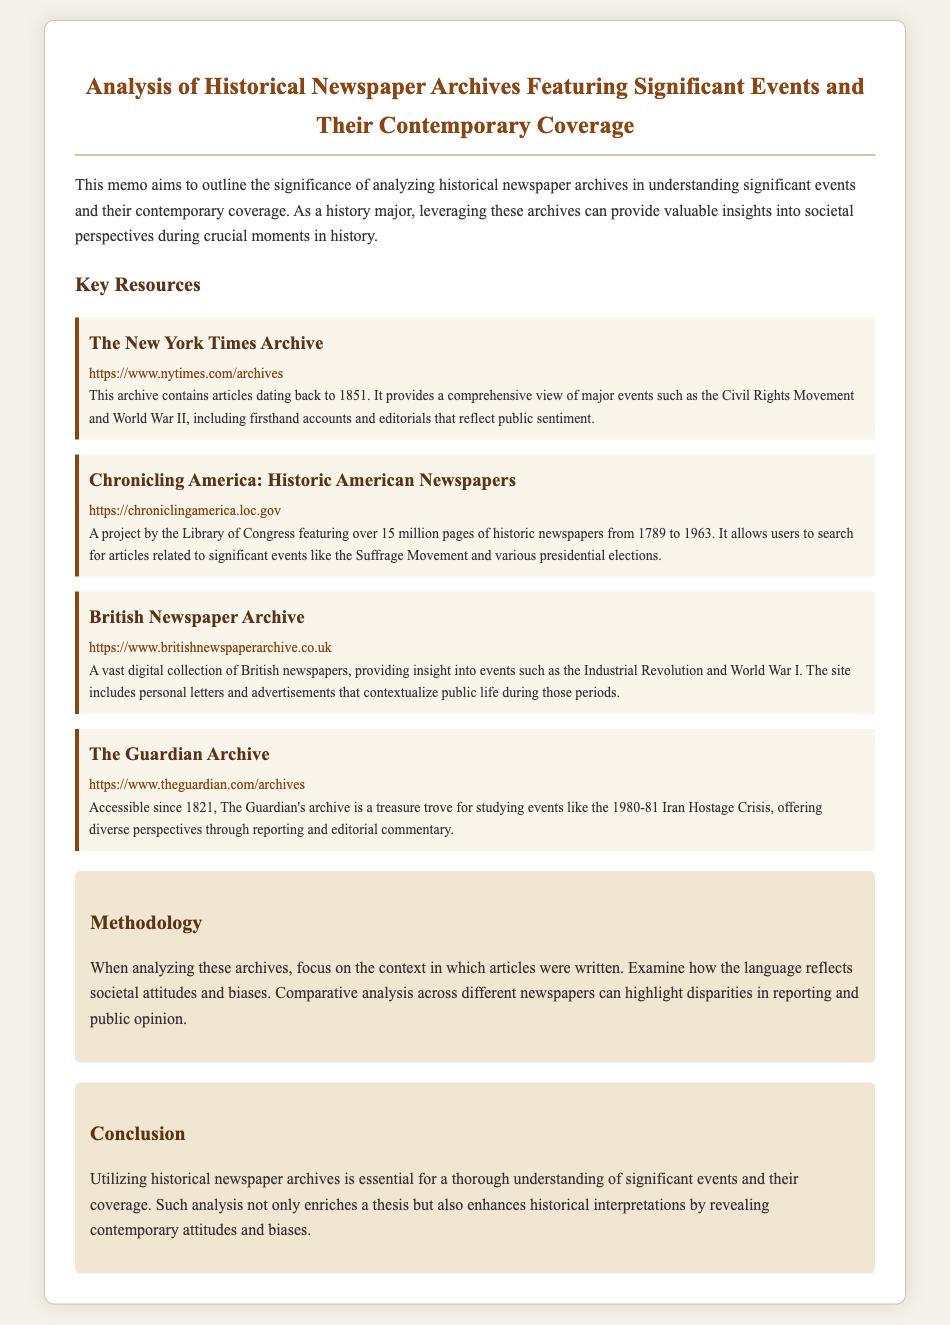What is the title of the memo? The title is the main heading of the document, which provides insight into its focus.
Answer: Analysis of Historical Newspaper Archives Featuring Significant Events and Their Contemporary Coverage What year does The New York Times Archive start? The document states that The New York Times Archive contains articles dating back to a specific year.
Answer: 1851 How many pages does Chronicling America feature? The document mentions the number of pages available in the Chronicling America project.
Answer: over 15 million pages What significant events can be researched in the British Newspaper Archive? The document highlights particular historical events that can be explored within this archive.
Answer: Industrial Revolution and World War I What is a suggested analysis method according to the memo? The memo provides a specific method for analyzing articles from the historical archives.
Answer: Comparative analysis Which archive contains articles accessible since 1821? The document specifies an archive and its historical accessibility year.
Answer: The Guardian Archive What does the methodology section emphasize for article analysis? The methodology section outlines a key aspect to focus on while analyzing articles.
Answer: Context in which articles were written What enhances historical interpretations according to the conclusion? The conclusion discusses what improves the understanding of historical events.
Answer: Analysis of historical newspaper archives 